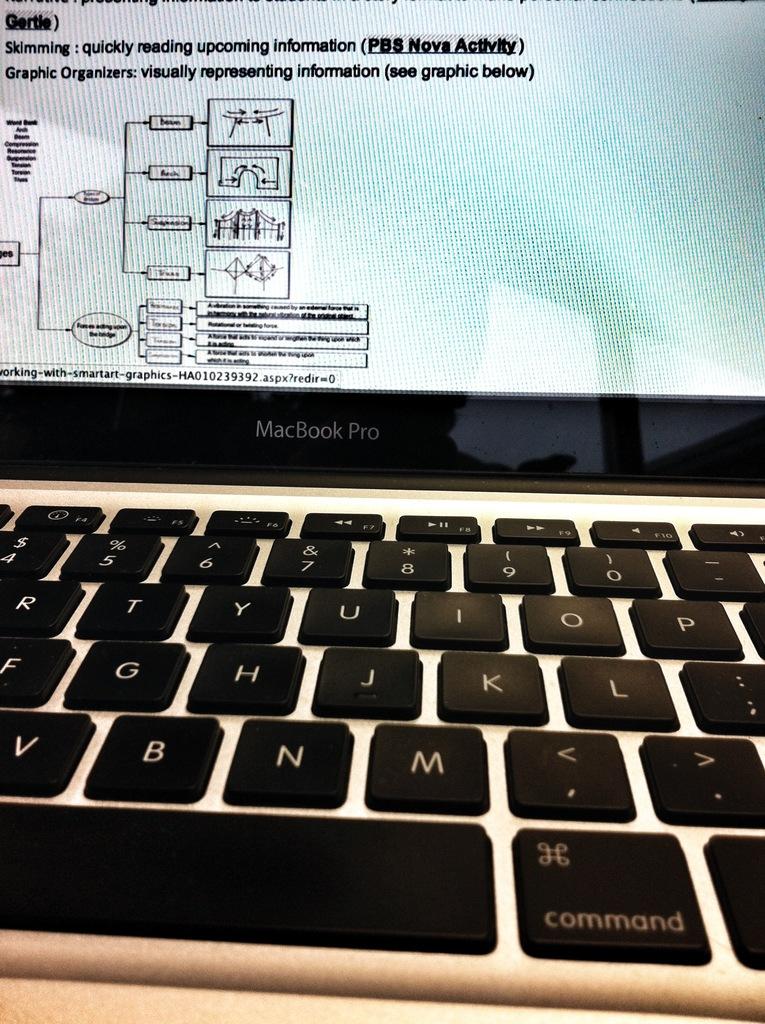What is the letter to the left of the key with a period?
Offer a very short reply. M. What type of laptop is this?
Ensure brevity in your answer.  Macbook pro. 